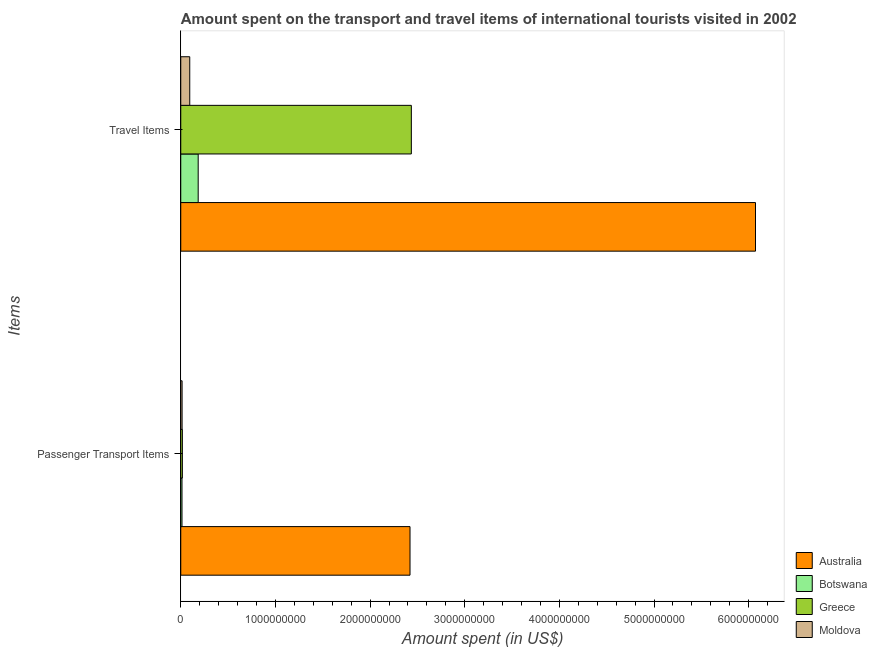How many different coloured bars are there?
Your answer should be compact. 4. How many groups of bars are there?
Provide a succinct answer. 2. How many bars are there on the 2nd tick from the bottom?
Give a very brief answer. 4. What is the label of the 1st group of bars from the top?
Offer a terse response. Travel Items. What is the amount spent on passenger transport items in Moldova?
Offer a terse response. 1.40e+07. Across all countries, what is the maximum amount spent on passenger transport items?
Ensure brevity in your answer.  2.42e+09. Across all countries, what is the minimum amount spent on passenger transport items?
Ensure brevity in your answer.  1.30e+07. In which country was the amount spent on passenger transport items maximum?
Your answer should be compact. Australia. In which country was the amount spent in travel items minimum?
Provide a short and direct response. Moldova. What is the total amount spent in travel items in the graph?
Ensure brevity in your answer.  8.79e+09. What is the difference between the amount spent on passenger transport items in Botswana and that in Greece?
Ensure brevity in your answer.  -4.00e+06. What is the difference between the amount spent on passenger transport items in Greece and the amount spent in travel items in Australia?
Ensure brevity in your answer.  -6.06e+09. What is the average amount spent in travel items per country?
Ensure brevity in your answer.  2.20e+09. What is the difference between the amount spent in travel items and amount spent on passenger transport items in Greece?
Give a very brief answer. 2.42e+09. In how many countries, is the amount spent on passenger transport items greater than 1200000000 US$?
Your answer should be very brief. 1. What is the ratio of the amount spent on passenger transport items in Greece to that in Botswana?
Give a very brief answer. 1.31. In how many countries, is the amount spent in travel items greater than the average amount spent in travel items taken over all countries?
Your response must be concise. 2. What does the 1st bar from the bottom in Travel Items represents?
Provide a succinct answer. Australia. How many bars are there?
Offer a very short reply. 8. Are the values on the major ticks of X-axis written in scientific E-notation?
Provide a succinct answer. No. Does the graph contain any zero values?
Keep it short and to the point. No. Does the graph contain grids?
Make the answer very short. No. Where does the legend appear in the graph?
Ensure brevity in your answer.  Bottom right. How many legend labels are there?
Your response must be concise. 4. How are the legend labels stacked?
Ensure brevity in your answer.  Vertical. What is the title of the graph?
Provide a succinct answer. Amount spent on the transport and travel items of international tourists visited in 2002. What is the label or title of the X-axis?
Provide a short and direct response. Amount spent (in US$). What is the label or title of the Y-axis?
Make the answer very short. Items. What is the Amount spent (in US$) in Australia in Passenger Transport Items?
Offer a very short reply. 2.42e+09. What is the Amount spent (in US$) of Botswana in Passenger Transport Items?
Your response must be concise. 1.30e+07. What is the Amount spent (in US$) of Greece in Passenger Transport Items?
Provide a succinct answer. 1.70e+07. What is the Amount spent (in US$) of Moldova in Passenger Transport Items?
Give a very brief answer. 1.40e+07. What is the Amount spent (in US$) in Australia in Travel Items?
Provide a succinct answer. 6.07e+09. What is the Amount spent (in US$) in Botswana in Travel Items?
Make the answer very short. 1.84e+08. What is the Amount spent (in US$) in Greece in Travel Items?
Offer a terse response. 2.44e+09. What is the Amount spent (in US$) in Moldova in Travel Items?
Your response must be concise. 9.50e+07. Across all Items, what is the maximum Amount spent (in US$) in Australia?
Offer a very short reply. 6.07e+09. Across all Items, what is the maximum Amount spent (in US$) in Botswana?
Keep it short and to the point. 1.84e+08. Across all Items, what is the maximum Amount spent (in US$) in Greece?
Make the answer very short. 2.44e+09. Across all Items, what is the maximum Amount spent (in US$) in Moldova?
Provide a succinct answer. 9.50e+07. Across all Items, what is the minimum Amount spent (in US$) in Australia?
Give a very brief answer. 2.42e+09. Across all Items, what is the minimum Amount spent (in US$) in Botswana?
Ensure brevity in your answer.  1.30e+07. Across all Items, what is the minimum Amount spent (in US$) in Greece?
Your response must be concise. 1.70e+07. Across all Items, what is the minimum Amount spent (in US$) of Moldova?
Give a very brief answer. 1.40e+07. What is the total Amount spent (in US$) in Australia in the graph?
Your answer should be very brief. 8.49e+09. What is the total Amount spent (in US$) in Botswana in the graph?
Keep it short and to the point. 1.97e+08. What is the total Amount spent (in US$) of Greece in the graph?
Provide a succinct answer. 2.45e+09. What is the total Amount spent (in US$) in Moldova in the graph?
Offer a terse response. 1.09e+08. What is the difference between the Amount spent (in US$) of Australia in Passenger Transport Items and that in Travel Items?
Your answer should be very brief. -3.65e+09. What is the difference between the Amount spent (in US$) in Botswana in Passenger Transport Items and that in Travel Items?
Provide a succinct answer. -1.71e+08. What is the difference between the Amount spent (in US$) of Greece in Passenger Transport Items and that in Travel Items?
Offer a terse response. -2.42e+09. What is the difference between the Amount spent (in US$) of Moldova in Passenger Transport Items and that in Travel Items?
Provide a short and direct response. -8.10e+07. What is the difference between the Amount spent (in US$) of Australia in Passenger Transport Items and the Amount spent (in US$) of Botswana in Travel Items?
Your answer should be very brief. 2.24e+09. What is the difference between the Amount spent (in US$) of Australia in Passenger Transport Items and the Amount spent (in US$) of Greece in Travel Items?
Offer a very short reply. -1.40e+07. What is the difference between the Amount spent (in US$) of Australia in Passenger Transport Items and the Amount spent (in US$) of Moldova in Travel Items?
Your answer should be very brief. 2.33e+09. What is the difference between the Amount spent (in US$) in Botswana in Passenger Transport Items and the Amount spent (in US$) in Greece in Travel Items?
Ensure brevity in your answer.  -2.42e+09. What is the difference between the Amount spent (in US$) in Botswana in Passenger Transport Items and the Amount spent (in US$) in Moldova in Travel Items?
Ensure brevity in your answer.  -8.20e+07. What is the difference between the Amount spent (in US$) in Greece in Passenger Transport Items and the Amount spent (in US$) in Moldova in Travel Items?
Ensure brevity in your answer.  -7.80e+07. What is the average Amount spent (in US$) of Australia per Items?
Give a very brief answer. 4.25e+09. What is the average Amount spent (in US$) of Botswana per Items?
Your answer should be very brief. 9.85e+07. What is the average Amount spent (in US$) of Greece per Items?
Offer a terse response. 1.23e+09. What is the average Amount spent (in US$) of Moldova per Items?
Offer a terse response. 5.45e+07. What is the difference between the Amount spent (in US$) of Australia and Amount spent (in US$) of Botswana in Passenger Transport Items?
Your answer should be very brief. 2.41e+09. What is the difference between the Amount spent (in US$) in Australia and Amount spent (in US$) in Greece in Passenger Transport Items?
Make the answer very short. 2.40e+09. What is the difference between the Amount spent (in US$) of Australia and Amount spent (in US$) of Moldova in Passenger Transport Items?
Make the answer very short. 2.41e+09. What is the difference between the Amount spent (in US$) of Botswana and Amount spent (in US$) of Greece in Passenger Transport Items?
Provide a succinct answer. -4.00e+06. What is the difference between the Amount spent (in US$) of Greece and Amount spent (in US$) of Moldova in Passenger Transport Items?
Provide a short and direct response. 3.00e+06. What is the difference between the Amount spent (in US$) of Australia and Amount spent (in US$) of Botswana in Travel Items?
Your answer should be compact. 5.89e+09. What is the difference between the Amount spent (in US$) in Australia and Amount spent (in US$) in Greece in Travel Items?
Your answer should be very brief. 3.64e+09. What is the difference between the Amount spent (in US$) in Australia and Amount spent (in US$) in Moldova in Travel Items?
Your response must be concise. 5.98e+09. What is the difference between the Amount spent (in US$) of Botswana and Amount spent (in US$) of Greece in Travel Items?
Your answer should be compact. -2.25e+09. What is the difference between the Amount spent (in US$) of Botswana and Amount spent (in US$) of Moldova in Travel Items?
Ensure brevity in your answer.  8.90e+07. What is the difference between the Amount spent (in US$) in Greece and Amount spent (in US$) in Moldova in Travel Items?
Ensure brevity in your answer.  2.34e+09. What is the ratio of the Amount spent (in US$) in Australia in Passenger Transport Items to that in Travel Items?
Offer a terse response. 0.4. What is the ratio of the Amount spent (in US$) in Botswana in Passenger Transport Items to that in Travel Items?
Your response must be concise. 0.07. What is the ratio of the Amount spent (in US$) of Greece in Passenger Transport Items to that in Travel Items?
Give a very brief answer. 0.01. What is the ratio of the Amount spent (in US$) of Moldova in Passenger Transport Items to that in Travel Items?
Ensure brevity in your answer.  0.15. What is the difference between the highest and the second highest Amount spent (in US$) in Australia?
Provide a short and direct response. 3.65e+09. What is the difference between the highest and the second highest Amount spent (in US$) in Botswana?
Provide a succinct answer. 1.71e+08. What is the difference between the highest and the second highest Amount spent (in US$) of Greece?
Give a very brief answer. 2.42e+09. What is the difference between the highest and the second highest Amount spent (in US$) of Moldova?
Your answer should be very brief. 8.10e+07. What is the difference between the highest and the lowest Amount spent (in US$) of Australia?
Your answer should be very brief. 3.65e+09. What is the difference between the highest and the lowest Amount spent (in US$) of Botswana?
Give a very brief answer. 1.71e+08. What is the difference between the highest and the lowest Amount spent (in US$) of Greece?
Offer a very short reply. 2.42e+09. What is the difference between the highest and the lowest Amount spent (in US$) of Moldova?
Provide a short and direct response. 8.10e+07. 